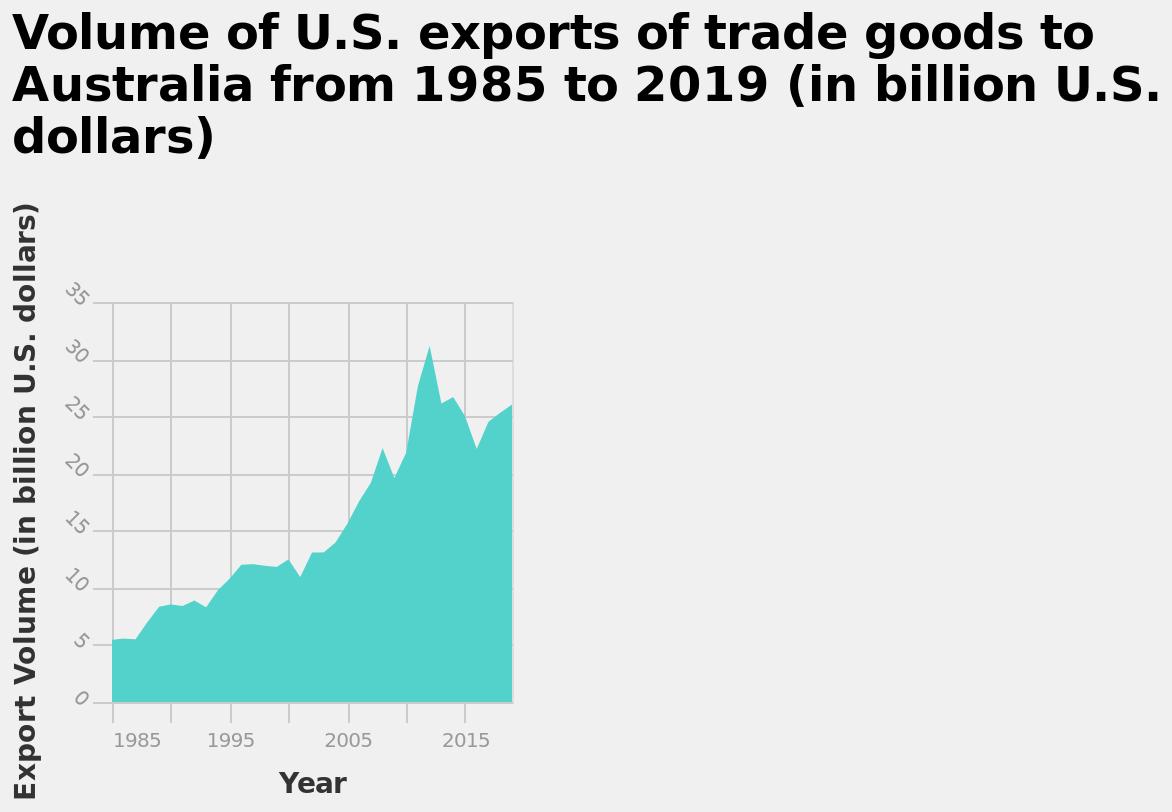<image>
What type of graph is being used to represent the data? An area graph is being used to represent the data. In what year does the graph end? The graph ends in the year 2019. What is the range of the y-axis on the graph?  The range of the y-axis is from 0 to 35 billion U.S. dollars. 